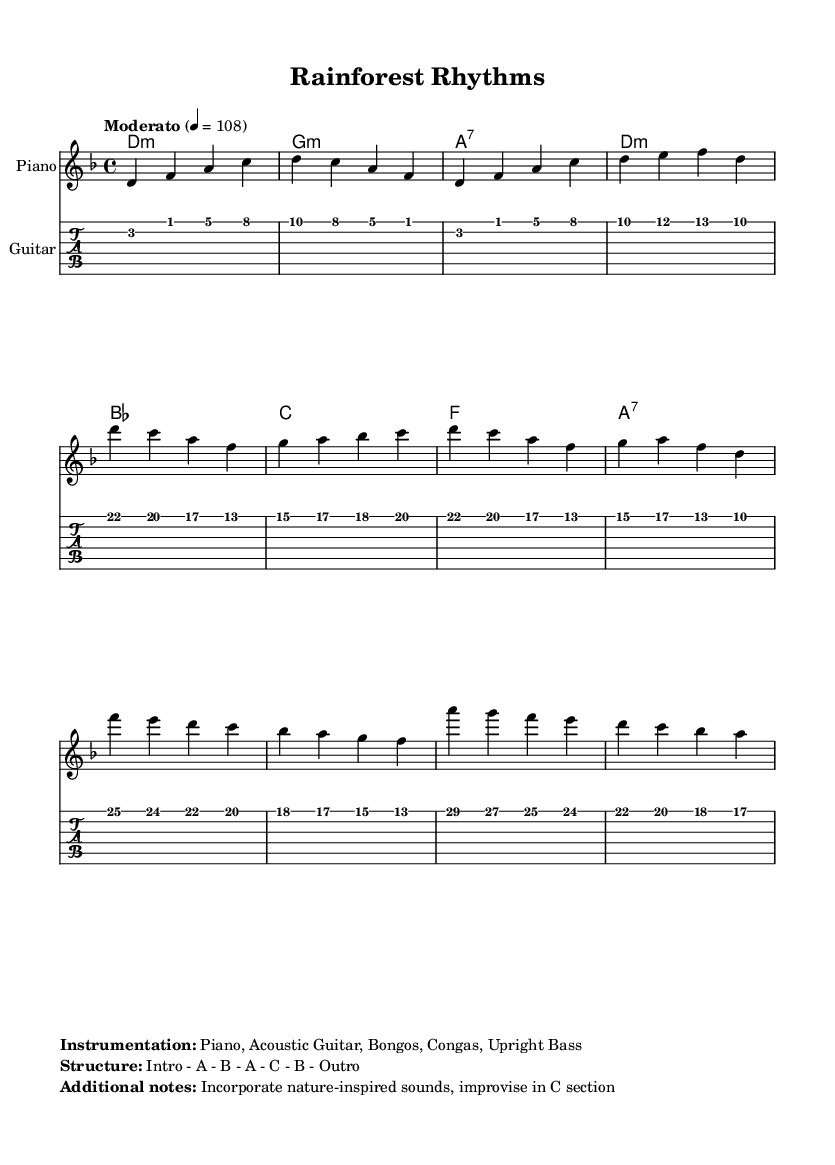What is the key signature of this music? The key signature is indicated at the beginning of the sheet music, which shows that there are two flats (B-flat and E-flat), indicating D minor.
Answer: D minor What is the time signature of this piece? The time signature is displayed at the beginning of the score as "4/4", indicating four beats per measure.
Answer: 4/4 What is the tempo marking for this composition? The tempo marking is found at the top of the sheet music, which states "Moderato" with a metronome marking of 108, indicating a moderate speed.
Answer: Moderato 4 = 108 What is the structure of the music? The structure is mentioned in the markup section clearly laid out as "Intro - A - B - A - C - B - Outro", specifying the sections of the piece.
Answer: Intro - A - B - A - C - B - Outro How many instruments are used in this arrangement? The instrumentation is specified in the markup, listing five instruments: Piano, Acoustic Guitar, Bongos, Congas, and Upright Bass.
Answer: Five instruments What style of improvisation is suggested for the C section? The additional notes in the markup mention to "incorporate nature-inspired sounds, improvise in C section", indicating that improvisation is encouraged.
Answer: Nature-inspired sounds 